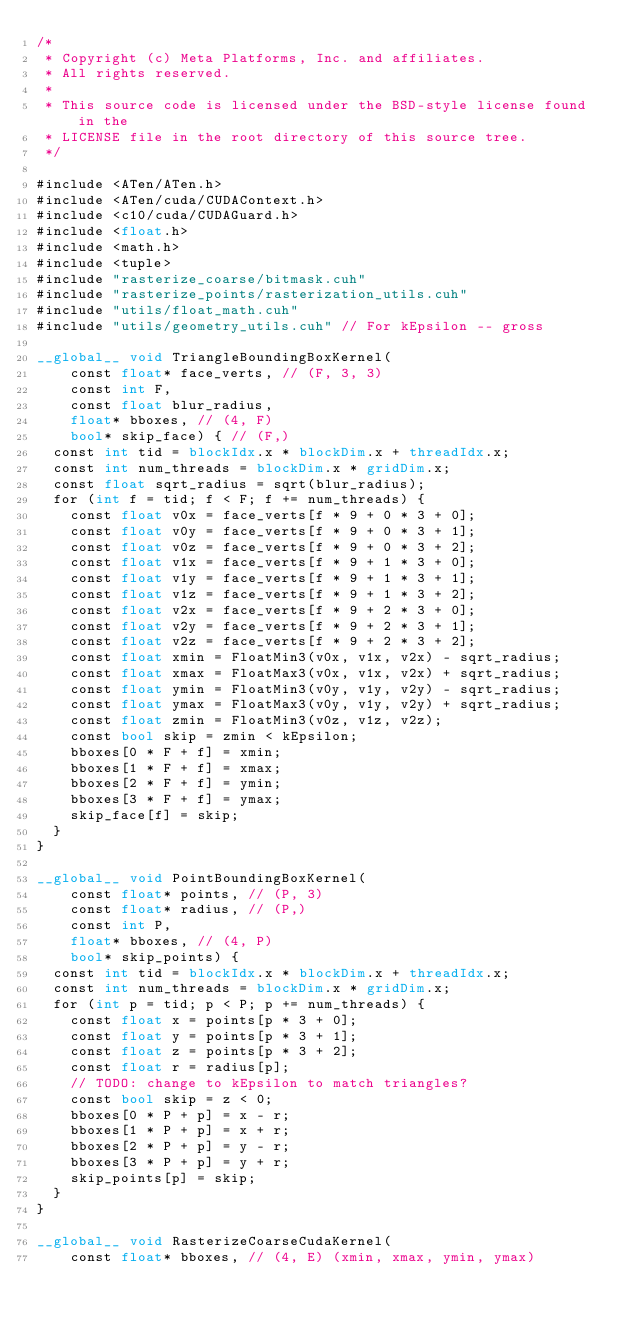<code> <loc_0><loc_0><loc_500><loc_500><_Cuda_>/*
 * Copyright (c) Meta Platforms, Inc. and affiliates.
 * All rights reserved.
 *
 * This source code is licensed under the BSD-style license found in the
 * LICENSE file in the root directory of this source tree.
 */

#include <ATen/ATen.h>
#include <ATen/cuda/CUDAContext.h>
#include <c10/cuda/CUDAGuard.h>
#include <float.h>
#include <math.h>
#include <tuple>
#include "rasterize_coarse/bitmask.cuh"
#include "rasterize_points/rasterization_utils.cuh"
#include "utils/float_math.cuh"
#include "utils/geometry_utils.cuh" // For kEpsilon -- gross

__global__ void TriangleBoundingBoxKernel(
    const float* face_verts, // (F, 3, 3)
    const int F,
    const float blur_radius,
    float* bboxes, // (4, F)
    bool* skip_face) { // (F,)
  const int tid = blockIdx.x * blockDim.x + threadIdx.x;
  const int num_threads = blockDim.x * gridDim.x;
  const float sqrt_radius = sqrt(blur_radius);
  for (int f = tid; f < F; f += num_threads) {
    const float v0x = face_verts[f * 9 + 0 * 3 + 0];
    const float v0y = face_verts[f * 9 + 0 * 3 + 1];
    const float v0z = face_verts[f * 9 + 0 * 3 + 2];
    const float v1x = face_verts[f * 9 + 1 * 3 + 0];
    const float v1y = face_verts[f * 9 + 1 * 3 + 1];
    const float v1z = face_verts[f * 9 + 1 * 3 + 2];
    const float v2x = face_verts[f * 9 + 2 * 3 + 0];
    const float v2y = face_verts[f * 9 + 2 * 3 + 1];
    const float v2z = face_verts[f * 9 + 2 * 3 + 2];
    const float xmin = FloatMin3(v0x, v1x, v2x) - sqrt_radius;
    const float xmax = FloatMax3(v0x, v1x, v2x) + sqrt_radius;
    const float ymin = FloatMin3(v0y, v1y, v2y) - sqrt_radius;
    const float ymax = FloatMax3(v0y, v1y, v2y) + sqrt_radius;
    const float zmin = FloatMin3(v0z, v1z, v2z);
    const bool skip = zmin < kEpsilon;
    bboxes[0 * F + f] = xmin;
    bboxes[1 * F + f] = xmax;
    bboxes[2 * F + f] = ymin;
    bboxes[3 * F + f] = ymax;
    skip_face[f] = skip;
  }
}

__global__ void PointBoundingBoxKernel(
    const float* points, // (P, 3)
    const float* radius, // (P,)
    const int P,
    float* bboxes, // (4, P)
    bool* skip_points) {
  const int tid = blockIdx.x * blockDim.x + threadIdx.x;
  const int num_threads = blockDim.x * gridDim.x;
  for (int p = tid; p < P; p += num_threads) {
    const float x = points[p * 3 + 0];
    const float y = points[p * 3 + 1];
    const float z = points[p * 3 + 2];
    const float r = radius[p];
    // TODO: change to kEpsilon to match triangles?
    const bool skip = z < 0;
    bboxes[0 * P + p] = x - r;
    bboxes[1 * P + p] = x + r;
    bboxes[2 * P + p] = y - r;
    bboxes[3 * P + p] = y + r;
    skip_points[p] = skip;
  }
}

__global__ void RasterizeCoarseCudaKernel(
    const float* bboxes, // (4, E) (xmin, xmax, ymin, ymax)</code> 